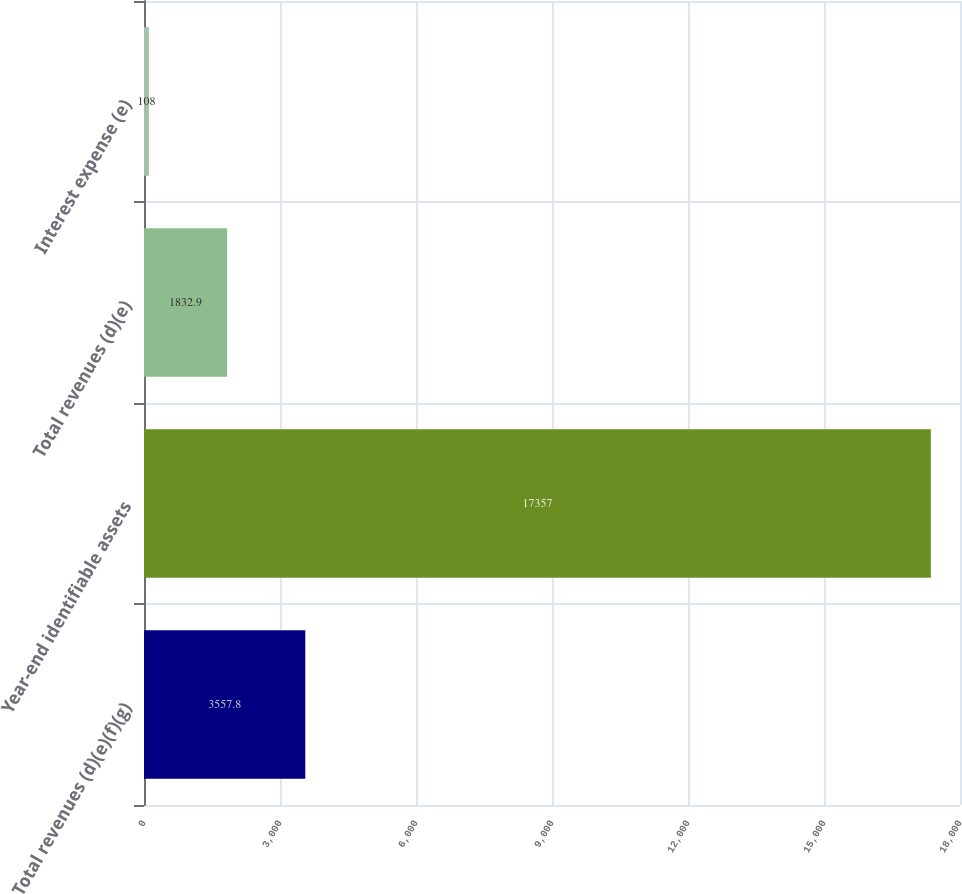Convert chart to OTSL. <chart><loc_0><loc_0><loc_500><loc_500><bar_chart><fcel>Total revenues (d)(e)(f)(g)<fcel>Year-end identifiable assets<fcel>Total revenues (d)(e)<fcel>Interest expense (e)<nl><fcel>3557.8<fcel>17357<fcel>1832.9<fcel>108<nl></chart> 